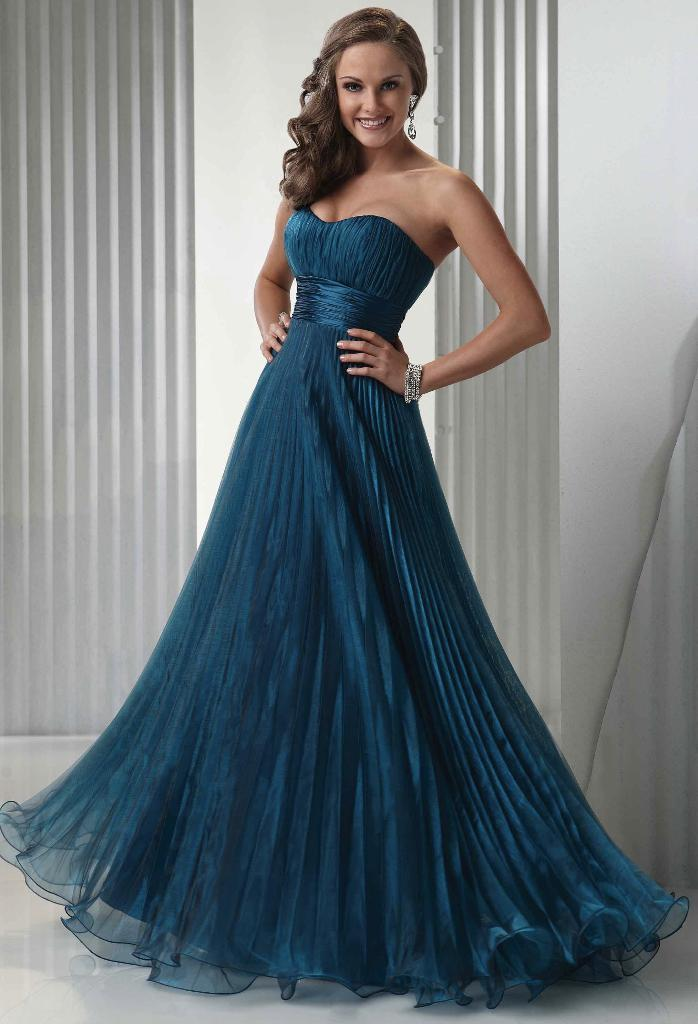Who is the main subject in the image? There is a lady in the image. What is the lady wearing? The lady is wearing a teal blue gown. What is the color of the floor where the lady is standing? The lady is standing on a white floor. What type of cheese is the lady holding in the image? There is no cheese present in the image; the lady is not holding anything. 